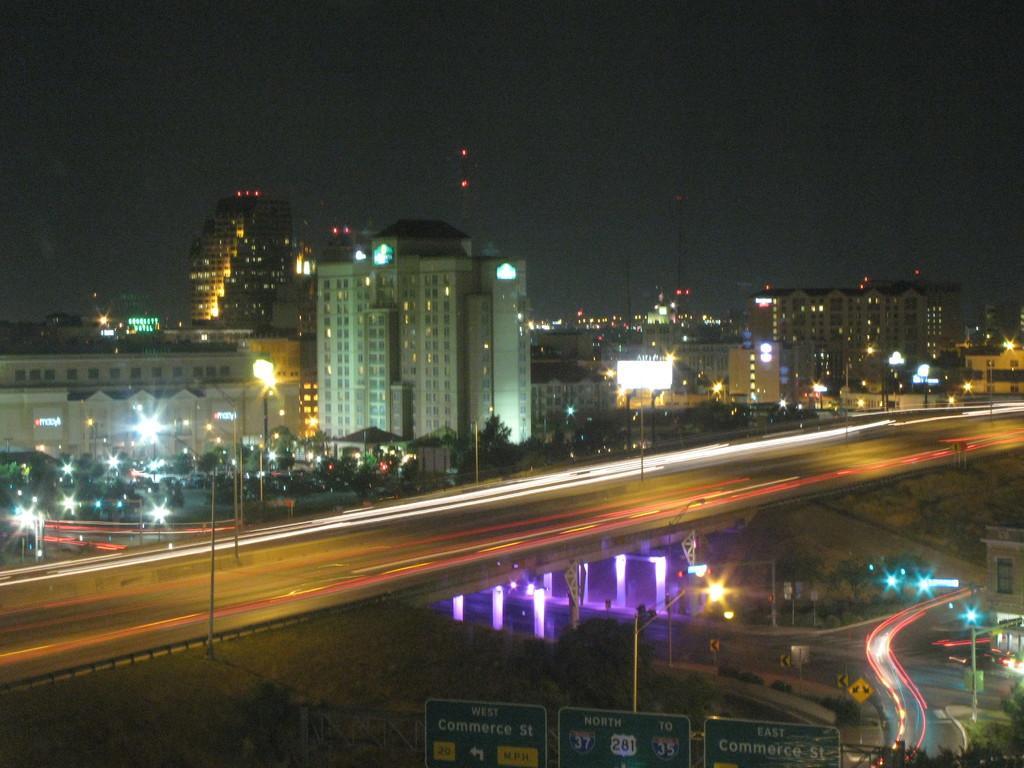In one or two sentences, can you explain what this image depicts? In this picture we can see a road, beside this road we can see buildings, lights, electric poles, trees, name boards, sign boards and some objects. We can see sky in the background. 